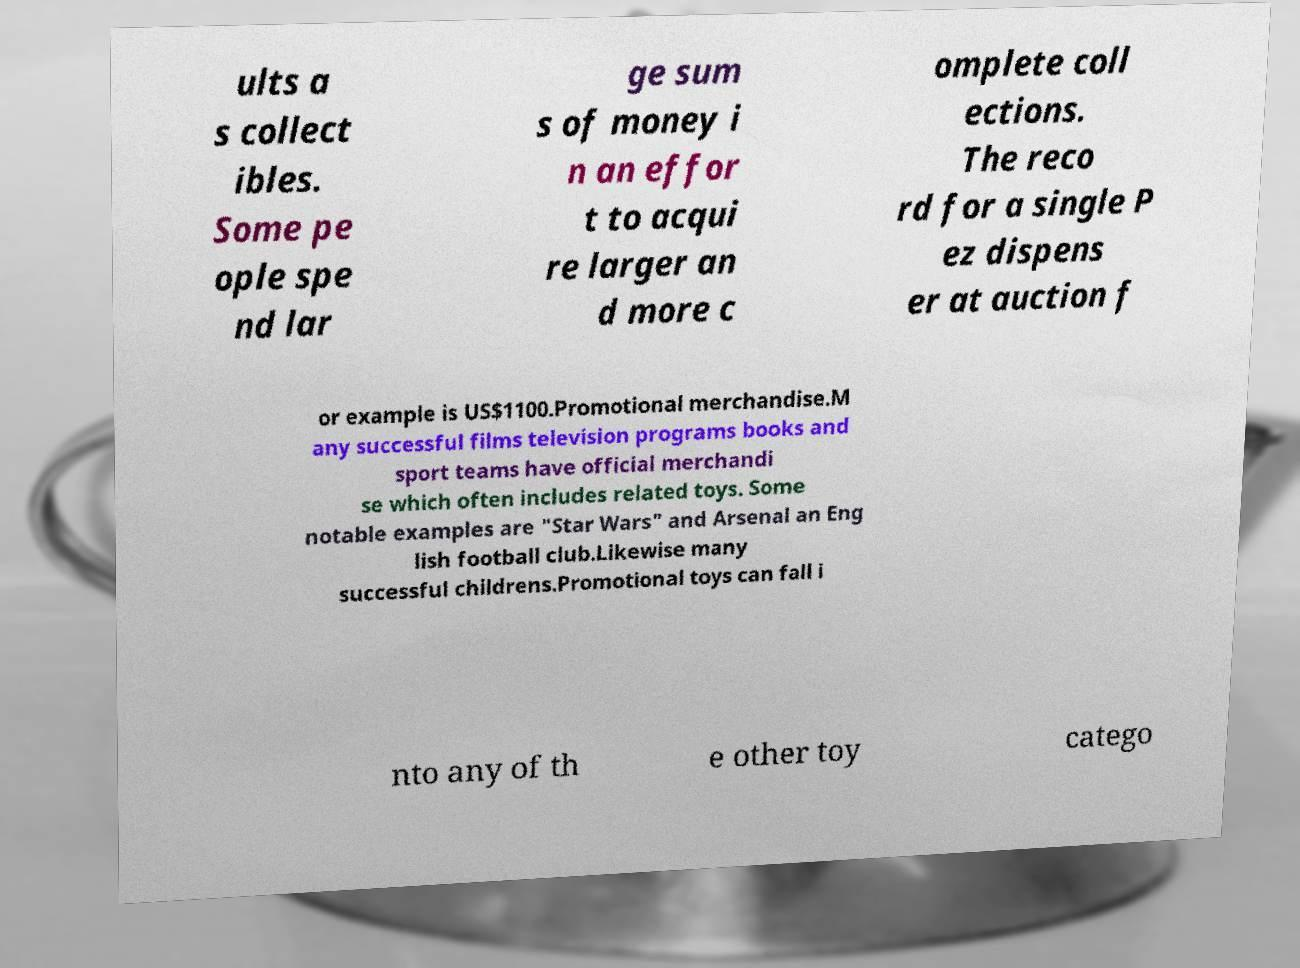Can you accurately transcribe the text from the provided image for me? ults a s collect ibles. Some pe ople spe nd lar ge sum s of money i n an effor t to acqui re larger an d more c omplete coll ections. The reco rd for a single P ez dispens er at auction f or example is US$1100.Promotional merchandise.M any successful films television programs books and sport teams have official merchandi se which often includes related toys. Some notable examples are "Star Wars" and Arsenal an Eng lish football club.Likewise many successful childrens.Promotional toys can fall i nto any of th e other toy catego 